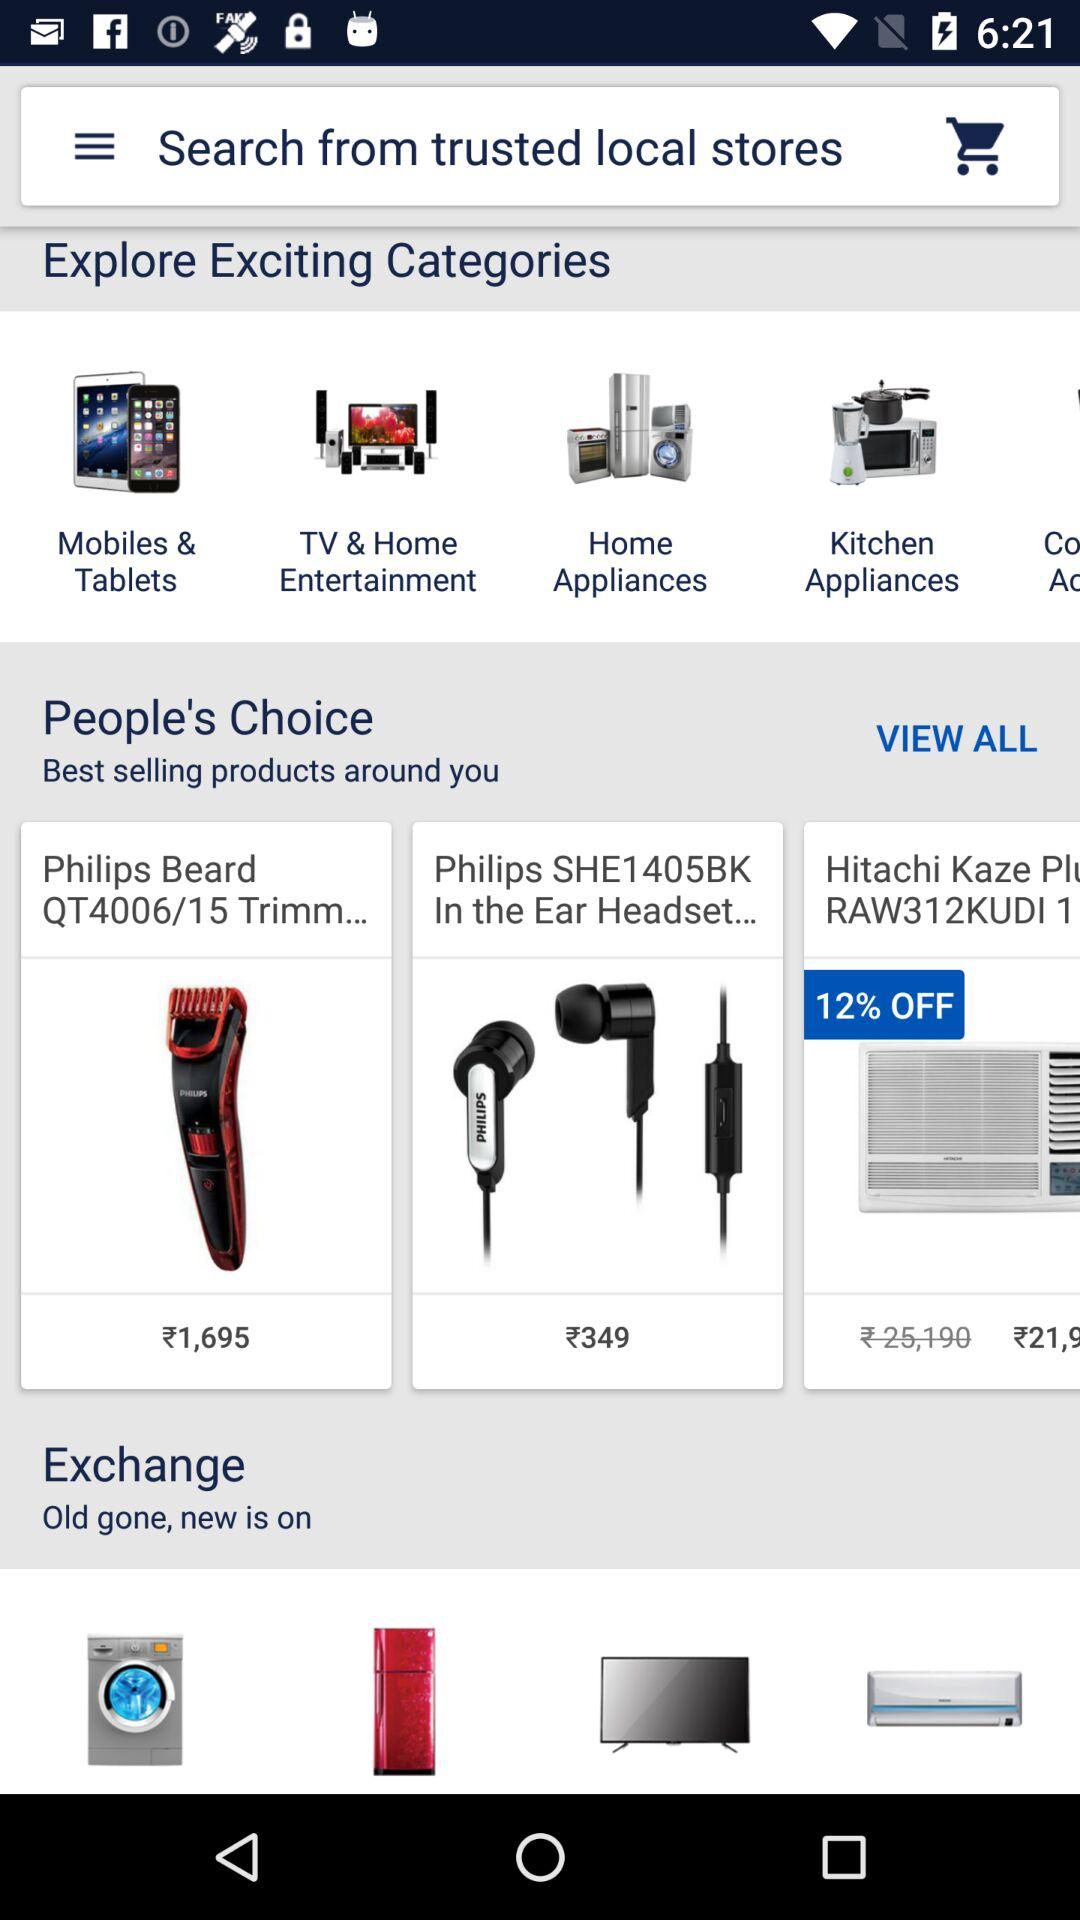What is the price of the "Philips SHE1405BK"? The price is ₹349. 